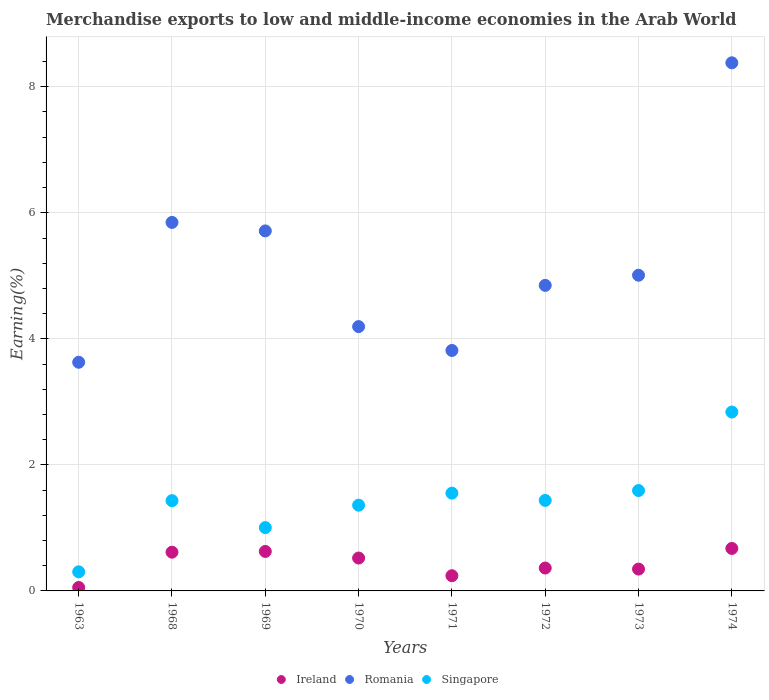How many different coloured dotlines are there?
Make the answer very short. 3. What is the percentage of amount earned from merchandise exports in Romania in 1974?
Your answer should be compact. 8.38. Across all years, what is the maximum percentage of amount earned from merchandise exports in Ireland?
Your answer should be very brief. 0.67. Across all years, what is the minimum percentage of amount earned from merchandise exports in Romania?
Give a very brief answer. 3.63. In which year was the percentage of amount earned from merchandise exports in Ireland maximum?
Your answer should be very brief. 1974. In which year was the percentage of amount earned from merchandise exports in Ireland minimum?
Keep it short and to the point. 1963. What is the total percentage of amount earned from merchandise exports in Singapore in the graph?
Provide a succinct answer. 11.52. What is the difference between the percentage of amount earned from merchandise exports in Singapore in 1972 and that in 1973?
Ensure brevity in your answer.  -0.16. What is the difference between the percentage of amount earned from merchandise exports in Ireland in 1969 and the percentage of amount earned from merchandise exports in Singapore in 1974?
Provide a short and direct response. -2.21. What is the average percentage of amount earned from merchandise exports in Romania per year?
Ensure brevity in your answer.  5.18. In the year 1971, what is the difference between the percentage of amount earned from merchandise exports in Romania and percentage of amount earned from merchandise exports in Singapore?
Your response must be concise. 2.26. In how many years, is the percentage of amount earned from merchandise exports in Romania greater than 4.8 %?
Offer a very short reply. 5. What is the ratio of the percentage of amount earned from merchandise exports in Romania in 1968 to that in 1970?
Keep it short and to the point. 1.39. Is the percentage of amount earned from merchandise exports in Ireland in 1968 less than that in 1969?
Provide a short and direct response. Yes. What is the difference between the highest and the second highest percentage of amount earned from merchandise exports in Romania?
Your response must be concise. 2.53. What is the difference between the highest and the lowest percentage of amount earned from merchandise exports in Romania?
Your response must be concise. 4.75. In how many years, is the percentage of amount earned from merchandise exports in Singapore greater than the average percentage of amount earned from merchandise exports in Singapore taken over all years?
Provide a succinct answer. 3. Is it the case that in every year, the sum of the percentage of amount earned from merchandise exports in Romania and percentage of amount earned from merchandise exports in Singapore  is greater than the percentage of amount earned from merchandise exports in Ireland?
Offer a terse response. Yes. Is the percentage of amount earned from merchandise exports in Singapore strictly greater than the percentage of amount earned from merchandise exports in Romania over the years?
Your answer should be compact. No. Does the graph contain any zero values?
Offer a terse response. No. What is the title of the graph?
Ensure brevity in your answer.  Merchandise exports to low and middle-income economies in the Arab World. Does "Maldives" appear as one of the legend labels in the graph?
Offer a terse response. No. What is the label or title of the X-axis?
Your response must be concise. Years. What is the label or title of the Y-axis?
Provide a short and direct response. Earning(%). What is the Earning(%) of Ireland in 1963?
Offer a very short reply. 0.05. What is the Earning(%) in Romania in 1963?
Ensure brevity in your answer.  3.63. What is the Earning(%) of Singapore in 1963?
Your response must be concise. 0.3. What is the Earning(%) of Ireland in 1968?
Give a very brief answer. 0.61. What is the Earning(%) of Romania in 1968?
Ensure brevity in your answer.  5.85. What is the Earning(%) of Singapore in 1968?
Offer a very short reply. 1.43. What is the Earning(%) of Ireland in 1969?
Your response must be concise. 0.63. What is the Earning(%) in Romania in 1969?
Your answer should be compact. 5.71. What is the Earning(%) in Singapore in 1969?
Provide a succinct answer. 1. What is the Earning(%) of Ireland in 1970?
Your answer should be compact. 0.52. What is the Earning(%) of Romania in 1970?
Ensure brevity in your answer.  4.19. What is the Earning(%) of Singapore in 1970?
Make the answer very short. 1.36. What is the Earning(%) in Ireland in 1971?
Make the answer very short. 0.24. What is the Earning(%) in Romania in 1971?
Your answer should be very brief. 3.82. What is the Earning(%) of Singapore in 1971?
Your answer should be very brief. 1.55. What is the Earning(%) of Ireland in 1972?
Make the answer very short. 0.36. What is the Earning(%) of Romania in 1972?
Provide a short and direct response. 4.85. What is the Earning(%) in Singapore in 1972?
Ensure brevity in your answer.  1.44. What is the Earning(%) in Ireland in 1973?
Provide a short and direct response. 0.35. What is the Earning(%) of Romania in 1973?
Make the answer very short. 5.01. What is the Earning(%) of Singapore in 1973?
Your answer should be compact. 1.59. What is the Earning(%) of Ireland in 1974?
Keep it short and to the point. 0.67. What is the Earning(%) in Romania in 1974?
Keep it short and to the point. 8.38. What is the Earning(%) of Singapore in 1974?
Your answer should be very brief. 2.84. Across all years, what is the maximum Earning(%) in Ireland?
Give a very brief answer. 0.67. Across all years, what is the maximum Earning(%) in Romania?
Your answer should be very brief. 8.38. Across all years, what is the maximum Earning(%) of Singapore?
Provide a succinct answer. 2.84. Across all years, what is the minimum Earning(%) of Ireland?
Your answer should be very brief. 0.05. Across all years, what is the minimum Earning(%) in Romania?
Ensure brevity in your answer.  3.63. Across all years, what is the minimum Earning(%) of Singapore?
Ensure brevity in your answer.  0.3. What is the total Earning(%) in Ireland in the graph?
Give a very brief answer. 3.44. What is the total Earning(%) of Romania in the graph?
Keep it short and to the point. 41.44. What is the total Earning(%) in Singapore in the graph?
Offer a very short reply. 11.52. What is the difference between the Earning(%) of Ireland in 1963 and that in 1968?
Ensure brevity in your answer.  -0.56. What is the difference between the Earning(%) of Romania in 1963 and that in 1968?
Provide a short and direct response. -2.22. What is the difference between the Earning(%) in Singapore in 1963 and that in 1968?
Offer a terse response. -1.13. What is the difference between the Earning(%) in Ireland in 1963 and that in 1969?
Make the answer very short. -0.57. What is the difference between the Earning(%) in Romania in 1963 and that in 1969?
Provide a short and direct response. -2.08. What is the difference between the Earning(%) of Singapore in 1963 and that in 1969?
Offer a terse response. -0.7. What is the difference between the Earning(%) of Ireland in 1963 and that in 1970?
Provide a succinct answer. -0.47. What is the difference between the Earning(%) in Romania in 1963 and that in 1970?
Offer a very short reply. -0.57. What is the difference between the Earning(%) of Singapore in 1963 and that in 1970?
Your answer should be very brief. -1.06. What is the difference between the Earning(%) of Ireland in 1963 and that in 1971?
Make the answer very short. -0.19. What is the difference between the Earning(%) of Romania in 1963 and that in 1971?
Your response must be concise. -0.19. What is the difference between the Earning(%) in Singapore in 1963 and that in 1971?
Make the answer very short. -1.25. What is the difference between the Earning(%) of Ireland in 1963 and that in 1972?
Your answer should be very brief. -0.31. What is the difference between the Earning(%) of Romania in 1963 and that in 1972?
Make the answer very short. -1.22. What is the difference between the Earning(%) of Singapore in 1963 and that in 1972?
Your answer should be very brief. -1.13. What is the difference between the Earning(%) in Ireland in 1963 and that in 1973?
Offer a terse response. -0.29. What is the difference between the Earning(%) in Romania in 1963 and that in 1973?
Offer a very short reply. -1.38. What is the difference between the Earning(%) in Singapore in 1963 and that in 1973?
Keep it short and to the point. -1.29. What is the difference between the Earning(%) of Ireland in 1963 and that in 1974?
Provide a short and direct response. -0.62. What is the difference between the Earning(%) in Romania in 1963 and that in 1974?
Offer a very short reply. -4.75. What is the difference between the Earning(%) of Singapore in 1963 and that in 1974?
Ensure brevity in your answer.  -2.54. What is the difference between the Earning(%) of Ireland in 1968 and that in 1969?
Make the answer very short. -0.01. What is the difference between the Earning(%) in Romania in 1968 and that in 1969?
Your answer should be very brief. 0.13. What is the difference between the Earning(%) of Singapore in 1968 and that in 1969?
Your answer should be compact. 0.43. What is the difference between the Earning(%) in Ireland in 1968 and that in 1970?
Provide a short and direct response. 0.09. What is the difference between the Earning(%) in Romania in 1968 and that in 1970?
Give a very brief answer. 1.65. What is the difference between the Earning(%) of Singapore in 1968 and that in 1970?
Offer a terse response. 0.07. What is the difference between the Earning(%) of Ireland in 1968 and that in 1971?
Provide a succinct answer. 0.37. What is the difference between the Earning(%) in Romania in 1968 and that in 1971?
Offer a very short reply. 2.03. What is the difference between the Earning(%) of Singapore in 1968 and that in 1971?
Ensure brevity in your answer.  -0.12. What is the difference between the Earning(%) in Ireland in 1968 and that in 1972?
Keep it short and to the point. 0.25. What is the difference between the Earning(%) of Singapore in 1968 and that in 1972?
Give a very brief answer. -0. What is the difference between the Earning(%) of Ireland in 1968 and that in 1973?
Make the answer very short. 0.27. What is the difference between the Earning(%) in Romania in 1968 and that in 1973?
Your answer should be compact. 0.84. What is the difference between the Earning(%) in Singapore in 1968 and that in 1973?
Offer a terse response. -0.16. What is the difference between the Earning(%) in Ireland in 1968 and that in 1974?
Keep it short and to the point. -0.06. What is the difference between the Earning(%) of Romania in 1968 and that in 1974?
Keep it short and to the point. -2.53. What is the difference between the Earning(%) of Singapore in 1968 and that in 1974?
Offer a terse response. -1.41. What is the difference between the Earning(%) in Ireland in 1969 and that in 1970?
Your answer should be very brief. 0.1. What is the difference between the Earning(%) in Romania in 1969 and that in 1970?
Make the answer very short. 1.52. What is the difference between the Earning(%) in Singapore in 1969 and that in 1970?
Your response must be concise. -0.36. What is the difference between the Earning(%) in Ireland in 1969 and that in 1971?
Your answer should be very brief. 0.39. What is the difference between the Earning(%) in Romania in 1969 and that in 1971?
Offer a terse response. 1.9. What is the difference between the Earning(%) in Singapore in 1969 and that in 1971?
Offer a terse response. -0.55. What is the difference between the Earning(%) of Ireland in 1969 and that in 1972?
Offer a very short reply. 0.26. What is the difference between the Earning(%) in Romania in 1969 and that in 1972?
Offer a very short reply. 0.86. What is the difference between the Earning(%) of Singapore in 1969 and that in 1972?
Make the answer very short. -0.43. What is the difference between the Earning(%) of Ireland in 1969 and that in 1973?
Provide a succinct answer. 0.28. What is the difference between the Earning(%) of Romania in 1969 and that in 1973?
Ensure brevity in your answer.  0.7. What is the difference between the Earning(%) of Singapore in 1969 and that in 1973?
Your answer should be compact. -0.59. What is the difference between the Earning(%) of Ireland in 1969 and that in 1974?
Your response must be concise. -0.05. What is the difference between the Earning(%) in Romania in 1969 and that in 1974?
Ensure brevity in your answer.  -2.67. What is the difference between the Earning(%) in Singapore in 1969 and that in 1974?
Make the answer very short. -1.83. What is the difference between the Earning(%) of Ireland in 1970 and that in 1971?
Your answer should be very brief. 0.28. What is the difference between the Earning(%) in Romania in 1970 and that in 1971?
Offer a very short reply. 0.38. What is the difference between the Earning(%) of Singapore in 1970 and that in 1971?
Ensure brevity in your answer.  -0.19. What is the difference between the Earning(%) in Ireland in 1970 and that in 1972?
Keep it short and to the point. 0.16. What is the difference between the Earning(%) in Romania in 1970 and that in 1972?
Your response must be concise. -0.65. What is the difference between the Earning(%) of Singapore in 1970 and that in 1972?
Ensure brevity in your answer.  -0.08. What is the difference between the Earning(%) in Ireland in 1970 and that in 1973?
Offer a terse response. 0.18. What is the difference between the Earning(%) of Romania in 1970 and that in 1973?
Your response must be concise. -0.82. What is the difference between the Earning(%) in Singapore in 1970 and that in 1973?
Your answer should be compact. -0.23. What is the difference between the Earning(%) of Ireland in 1970 and that in 1974?
Your response must be concise. -0.15. What is the difference between the Earning(%) in Romania in 1970 and that in 1974?
Offer a very short reply. -4.19. What is the difference between the Earning(%) of Singapore in 1970 and that in 1974?
Provide a succinct answer. -1.48. What is the difference between the Earning(%) in Ireland in 1971 and that in 1972?
Make the answer very short. -0.12. What is the difference between the Earning(%) in Romania in 1971 and that in 1972?
Offer a very short reply. -1.03. What is the difference between the Earning(%) in Singapore in 1971 and that in 1972?
Offer a terse response. 0.11. What is the difference between the Earning(%) in Ireland in 1971 and that in 1973?
Your answer should be very brief. -0.11. What is the difference between the Earning(%) of Romania in 1971 and that in 1973?
Make the answer very short. -1.19. What is the difference between the Earning(%) of Singapore in 1971 and that in 1973?
Provide a succinct answer. -0.04. What is the difference between the Earning(%) in Ireland in 1971 and that in 1974?
Your response must be concise. -0.43. What is the difference between the Earning(%) of Romania in 1971 and that in 1974?
Your response must be concise. -4.56. What is the difference between the Earning(%) of Singapore in 1971 and that in 1974?
Your answer should be compact. -1.29. What is the difference between the Earning(%) of Ireland in 1972 and that in 1973?
Provide a succinct answer. 0.02. What is the difference between the Earning(%) in Romania in 1972 and that in 1973?
Ensure brevity in your answer.  -0.16. What is the difference between the Earning(%) of Singapore in 1972 and that in 1973?
Provide a succinct answer. -0.16. What is the difference between the Earning(%) of Ireland in 1972 and that in 1974?
Make the answer very short. -0.31. What is the difference between the Earning(%) of Romania in 1972 and that in 1974?
Provide a succinct answer. -3.53. What is the difference between the Earning(%) of Singapore in 1972 and that in 1974?
Your response must be concise. -1.4. What is the difference between the Earning(%) of Ireland in 1973 and that in 1974?
Your answer should be very brief. -0.33. What is the difference between the Earning(%) of Romania in 1973 and that in 1974?
Offer a terse response. -3.37. What is the difference between the Earning(%) in Singapore in 1973 and that in 1974?
Your answer should be compact. -1.25. What is the difference between the Earning(%) in Ireland in 1963 and the Earning(%) in Romania in 1968?
Provide a succinct answer. -5.79. What is the difference between the Earning(%) in Ireland in 1963 and the Earning(%) in Singapore in 1968?
Your answer should be very brief. -1.38. What is the difference between the Earning(%) of Romania in 1963 and the Earning(%) of Singapore in 1968?
Make the answer very short. 2.2. What is the difference between the Earning(%) in Ireland in 1963 and the Earning(%) in Romania in 1969?
Provide a succinct answer. -5.66. What is the difference between the Earning(%) of Ireland in 1963 and the Earning(%) of Singapore in 1969?
Your answer should be very brief. -0.95. What is the difference between the Earning(%) of Romania in 1963 and the Earning(%) of Singapore in 1969?
Provide a succinct answer. 2.62. What is the difference between the Earning(%) in Ireland in 1963 and the Earning(%) in Romania in 1970?
Make the answer very short. -4.14. What is the difference between the Earning(%) in Ireland in 1963 and the Earning(%) in Singapore in 1970?
Offer a very short reply. -1.31. What is the difference between the Earning(%) in Romania in 1963 and the Earning(%) in Singapore in 1970?
Provide a short and direct response. 2.27. What is the difference between the Earning(%) in Ireland in 1963 and the Earning(%) in Romania in 1971?
Your answer should be very brief. -3.76. What is the difference between the Earning(%) of Ireland in 1963 and the Earning(%) of Singapore in 1971?
Your answer should be compact. -1.5. What is the difference between the Earning(%) of Romania in 1963 and the Earning(%) of Singapore in 1971?
Provide a short and direct response. 2.08. What is the difference between the Earning(%) of Ireland in 1963 and the Earning(%) of Romania in 1972?
Your answer should be compact. -4.79. What is the difference between the Earning(%) of Ireland in 1963 and the Earning(%) of Singapore in 1972?
Provide a succinct answer. -1.38. What is the difference between the Earning(%) in Romania in 1963 and the Earning(%) in Singapore in 1972?
Make the answer very short. 2.19. What is the difference between the Earning(%) in Ireland in 1963 and the Earning(%) in Romania in 1973?
Provide a short and direct response. -4.95. What is the difference between the Earning(%) of Ireland in 1963 and the Earning(%) of Singapore in 1973?
Keep it short and to the point. -1.54. What is the difference between the Earning(%) of Romania in 1963 and the Earning(%) of Singapore in 1973?
Your answer should be compact. 2.04. What is the difference between the Earning(%) in Ireland in 1963 and the Earning(%) in Romania in 1974?
Give a very brief answer. -8.33. What is the difference between the Earning(%) of Ireland in 1963 and the Earning(%) of Singapore in 1974?
Your answer should be compact. -2.78. What is the difference between the Earning(%) in Romania in 1963 and the Earning(%) in Singapore in 1974?
Provide a succinct answer. 0.79. What is the difference between the Earning(%) of Ireland in 1968 and the Earning(%) of Romania in 1969?
Make the answer very short. -5.1. What is the difference between the Earning(%) in Ireland in 1968 and the Earning(%) in Singapore in 1969?
Provide a succinct answer. -0.39. What is the difference between the Earning(%) of Romania in 1968 and the Earning(%) of Singapore in 1969?
Provide a succinct answer. 4.84. What is the difference between the Earning(%) in Ireland in 1968 and the Earning(%) in Romania in 1970?
Give a very brief answer. -3.58. What is the difference between the Earning(%) of Ireland in 1968 and the Earning(%) of Singapore in 1970?
Give a very brief answer. -0.75. What is the difference between the Earning(%) in Romania in 1968 and the Earning(%) in Singapore in 1970?
Provide a short and direct response. 4.49. What is the difference between the Earning(%) in Ireland in 1968 and the Earning(%) in Romania in 1971?
Your answer should be very brief. -3.2. What is the difference between the Earning(%) in Ireland in 1968 and the Earning(%) in Singapore in 1971?
Your answer should be very brief. -0.94. What is the difference between the Earning(%) of Romania in 1968 and the Earning(%) of Singapore in 1971?
Give a very brief answer. 4.3. What is the difference between the Earning(%) of Ireland in 1968 and the Earning(%) of Romania in 1972?
Make the answer very short. -4.23. What is the difference between the Earning(%) of Ireland in 1968 and the Earning(%) of Singapore in 1972?
Provide a succinct answer. -0.82. What is the difference between the Earning(%) of Romania in 1968 and the Earning(%) of Singapore in 1972?
Your answer should be compact. 4.41. What is the difference between the Earning(%) of Ireland in 1968 and the Earning(%) of Romania in 1973?
Provide a succinct answer. -4.39. What is the difference between the Earning(%) of Ireland in 1968 and the Earning(%) of Singapore in 1973?
Your answer should be compact. -0.98. What is the difference between the Earning(%) in Romania in 1968 and the Earning(%) in Singapore in 1973?
Your answer should be very brief. 4.25. What is the difference between the Earning(%) of Ireland in 1968 and the Earning(%) of Romania in 1974?
Ensure brevity in your answer.  -7.77. What is the difference between the Earning(%) in Ireland in 1968 and the Earning(%) in Singapore in 1974?
Offer a terse response. -2.22. What is the difference between the Earning(%) of Romania in 1968 and the Earning(%) of Singapore in 1974?
Your answer should be very brief. 3.01. What is the difference between the Earning(%) in Ireland in 1969 and the Earning(%) in Romania in 1970?
Your answer should be very brief. -3.57. What is the difference between the Earning(%) in Ireland in 1969 and the Earning(%) in Singapore in 1970?
Give a very brief answer. -0.73. What is the difference between the Earning(%) in Romania in 1969 and the Earning(%) in Singapore in 1970?
Make the answer very short. 4.35. What is the difference between the Earning(%) in Ireland in 1969 and the Earning(%) in Romania in 1971?
Provide a succinct answer. -3.19. What is the difference between the Earning(%) of Ireland in 1969 and the Earning(%) of Singapore in 1971?
Provide a succinct answer. -0.92. What is the difference between the Earning(%) in Romania in 1969 and the Earning(%) in Singapore in 1971?
Your response must be concise. 4.16. What is the difference between the Earning(%) in Ireland in 1969 and the Earning(%) in Romania in 1972?
Provide a short and direct response. -4.22. What is the difference between the Earning(%) of Ireland in 1969 and the Earning(%) of Singapore in 1972?
Provide a succinct answer. -0.81. What is the difference between the Earning(%) of Romania in 1969 and the Earning(%) of Singapore in 1972?
Give a very brief answer. 4.28. What is the difference between the Earning(%) of Ireland in 1969 and the Earning(%) of Romania in 1973?
Offer a terse response. -4.38. What is the difference between the Earning(%) in Ireland in 1969 and the Earning(%) in Singapore in 1973?
Provide a succinct answer. -0.97. What is the difference between the Earning(%) in Romania in 1969 and the Earning(%) in Singapore in 1973?
Offer a terse response. 4.12. What is the difference between the Earning(%) in Ireland in 1969 and the Earning(%) in Romania in 1974?
Keep it short and to the point. -7.75. What is the difference between the Earning(%) in Ireland in 1969 and the Earning(%) in Singapore in 1974?
Your answer should be compact. -2.21. What is the difference between the Earning(%) of Romania in 1969 and the Earning(%) of Singapore in 1974?
Offer a terse response. 2.87. What is the difference between the Earning(%) of Ireland in 1970 and the Earning(%) of Romania in 1971?
Your answer should be compact. -3.29. What is the difference between the Earning(%) in Ireland in 1970 and the Earning(%) in Singapore in 1971?
Provide a succinct answer. -1.03. What is the difference between the Earning(%) in Romania in 1970 and the Earning(%) in Singapore in 1971?
Ensure brevity in your answer.  2.64. What is the difference between the Earning(%) in Ireland in 1970 and the Earning(%) in Romania in 1972?
Keep it short and to the point. -4.33. What is the difference between the Earning(%) of Ireland in 1970 and the Earning(%) of Singapore in 1972?
Provide a short and direct response. -0.91. What is the difference between the Earning(%) in Romania in 1970 and the Earning(%) in Singapore in 1972?
Make the answer very short. 2.76. What is the difference between the Earning(%) in Ireland in 1970 and the Earning(%) in Romania in 1973?
Offer a very short reply. -4.49. What is the difference between the Earning(%) of Ireland in 1970 and the Earning(%) of Singapore in 1973?
Offer a terse response. -1.07. What is the difference between the Earning(%) in Romania in 1970 and the Earning(%) in Singapore in 1973?
Offer a terse response. 2.6. What is the difference between the Earning(%) of Ireland in 1970 and the Earning(%) of Romania in 1974?
Offer a terse response. -7.86. What is the difference between the Earning(%) of Ireland in 1970 and the Earning(%) of Singapore in 1974?
Make the answer very short. -2.32. What is the difference between the Earning(%) in Romania in 1970 and the Earning(%) in Singapore in 1974?
Provide a short and direct response. 1.36. What is the difference between the Earning(%) in Ireland in 1971 and the Earning(%) in Romania in 1972?
Make the answer very short. -4.61. What is the difference between the Earning(%) in Ireland in 1971 and the Earning(%) in Singapore in 1972?
Offer a terse response. -1.2. What is the difference between the Earning(%) of Romania in 1971 and the Earning(%) of Singapore in 1972?
Offer a terse response. 2.38. What is the difference between the Earning(%) in Ireland in 1971 and the Earning(%) in Romania in 1973?
Ensure brevity in your answer.  -4.77. What is the difference between the Earning(%) of Ireland in 1971 and the Earning(%) of Singapore in 1973?
Your response must be concise. -1.35. What is the difference between the Earning(%) of Romania in 1971 and the Earning(%) of Singapore in 1973?
Make the answer very short. 2.22. What is the difference between the Earning(%) in Ireland in 1971 and the Earning(%) in Romania in 1974?
Keep it short and to the point. -8.14. What is the difference between the Earning(%) of Ireland in 1971 and the Earning(%) of Singapore in 1974?
Provide a short and direct response. -2.6. What is the difference between the Earning(%) in Romania in 1971 and the Earning(%) in Singapore in 1974?
Offer a very short reply. 0.98. What is the difference between the Earning(%) in Ireland in 1972 and the Earning(%) in Romania in 1973?
Ensure brevity in your answer.  -4.65. What is the difference between the Earning(%) in Ireland in 1972 and the Earning(%) in Singapore in 1973?
Make the answer very short. -1.23. What is the difference between the Earning(%) in Romania in 1972 and the Earning(%) in Singapore in 1973?
Provide a succinct answer. 3.26. What is the difference between the Earning(%) in Ireland in 1972 and the Earning(%) in Romania in 1974?
Your answer should be compact. -8.02. What is the difference between the Earning(%) in Ireland in 1972 and the Earning(%) in Singapore in 1974?
Make the answer very short. -2.48. What is the difference between the Earning(%) of Romania in 1972 and the Earning(%) of Singapore in 1974?
Offer a terse response. 2.01. What is the difference between the Earning(%) of Ireland in 1973 and the Earning(%) of Romania in 1974?
Give a very brief answer. -8.03. What is the difference between the Earning(%) of Ireland in 1973 and the Earning(%) of Singapore in 1974?
Ensure brevity in your answer.  -2.49. What is the difference between the Earning(%) of Romania in 1973 and the Earning(%) of Singapore in 1974?
Offer a very short reply. 2.17. What is the average Earning(%) of Ireland per year?
Offer a terse response. 0.43. What is the average Earning(%) in Romania per year?
Offer a very short reply. 5.18. What is the average Earning(%) in Singapore per year?
Provide a succinct answer. 1.44. In the year 1963, what is the difference between the Earning(%) of Ireland and Earning(%) of Romania?
Provide a succinct answer. -3.57. In the year 1963, what is the difference between the Earning(%) of Ireland and Earning(%) of Singapore?
Keep it short and to the point. -0.25. In the year 1963, what is the difference between the Earning(%) in Romania and Earning(%) in Singapore?
Keep it short and to the point. 3.33. In the year 1968, what is the difference between the Earning(%) of Ireland and Earning(%) of Romania?
Keep it short and to the point. -5.23. In the year 1968, what is the difference between the Earning(%) of Ireland and Earning(%) of Singapore?
Keep it short and to the point. -0.82. In the year 1968, what is the difference between the Earning(%) in Romania and Earning(%) in Singapore?
Offer a very short reply. 4.42. In the year 1969, what is the difference between the Earning(%) of Ireland and Earning(%) of Romania?
Your response must be concise. -5.09. In the year 1969, what is the difference between the Earning(%) of Ireland and Earning(%) of Singapore?
Make the answer very short. -0.38. In the year 1969, what is the difference between the Earning(%) of Romania and Earning(%) of Singapore?
Ensure brevity in your answer.  4.71. In the year 1970, what is the difference between the Earning(%) of Ireland and Earning(%) of Romania?
Ensure brevity in your answer.  -3.67. In the year 1970, what is the difference between the Earning(%) in Ireland and Earning(%) in Singapore?
Ensure brevity in your answer.  -0.84. In the year 1970, what is the difference between the Earning(%) of Romania and Earning(%) of Singapore?
Offer a very short reply. 2.83. In the year 1971, what is the difference between the Earning(%) in Ireland and Earning(%) in Romania?
Your answer should be very brief. -3.57. In the year 1971, what is the difference between the Earning(%) in Ireland and Earning(%) in Singapore?
Provide a succinct answer. -1.31. In the year 1971, what is the difference between the Earning(%) of Romania and Earning(%) of Singapore?
Provide a short and direct response. 2.26. In the year 1972, what is the difference between the Earning(%) of Ireland and Earning(%) of Romania?
Offer a terse response. -4.49. In the year 1972, what is the difference between the Earning(%) in Ireland and Earning(%) in Singapore?
Offer a very short reply. -1.07. In the year 1972, what is the difference between the Earning(%) of Romania and Earning(%) of Singapore?
Give a very brief answer. 3.41. In the year 1973, what is the difference between the Earning(%) in Ireland and Earning(%) in Romania?
Provide a succinct answer. -4.66. In the year 1973, what is the difference between the Earning(%) in Ireland and Earning(%) in Singapore?
Your response must be concise. -1.25. In the year 1973, what is the difference between the Earning(%) in Romania and Earning(%) in Singapore?
Your answer should be very brief. 3.42. In the year 1974, what is the difference between the Earning(%) in Ireland and Earning(%) in Romania?
Give a very brief answer. -7.71. In the year 1974, what is the difference between the Earning(%) in Ireland and Earning(%) in Singapore?
Keep it short and to the point. -2.16. In the year 1974, what is the difference between the Earning(%) in Romania and Earning(%) in Singapore?
Your answer should be compact. 5.54. What is the ratio of the Earning(%) of Ireland in 1963 to that in 1968?
Your response must be concise. 0.09. What is the ratio of the Earning(%) in Romania in 1963 to that in 1968?
Your answer should be compact. 0.62. What is the ratio of the Earning(%) of Singapore in 1963 to that in 1968?
Provide a succinct answer. 0.21. What is the ratio of the Earning(%) in Ireland in 1963 to that in 1969?
Your answer should be compact. 0.09. What is the ratio of the Earning(%) of Romania in 1963 to that in 1969?
Keep it short and to the point. 0.64. What is the ratio of the Earning(%) in Singapore in 1963 to that in 1969?
Offer a terse response. 0.3. What is the ratio of the Earning(%) in Ireland in 1963 to that in 1970?
Keep it short and to the point. 0.1. What is the ratio of the Earning(%) of Romania in 1963 to that in 1970?
Your answer should be very brief. 0.87. What is the ratio of the Earning(%) of Singapore in 1963 to that in 1970?
Offer a terse response. 0.22. What is the ratio of the Earning(%) in Ireland in 1963 to that in 1971?
Keep it short and to the point. 0.23. What is the ratio of the Earning(%) of Romania in 1963 to that in 1971?
Provide a short and direct response. 0.95. What is the ratio of the Earning(%) of Singapore in 1963 to that in 1971?
Offer a very short reply. 0.2. What is the ratio of the Earning(%) in Ireland in 1963 to that in 1972?
Keep it short and to the point. 0.15. What is the ratio of the Earning(%) of Romania in 1963 to that in 1972?
Offer a very short reply. 0.75. What is the ratio of the Earning(%) of Singapore in 1963 to that in 1972?
Provide a short and direct response. 0.21. What is the ratio of the Earning(%) of Ireland in 1963 to that in 1973?
Your answer should be compact. 0.16. What is the ratio of the Earning(%) of Romania in 1963 to that in 1973?
Ensure brevity in your answer.  0.72. What is the ratio of the Earning(%) of Singapore in 1963 to that in 1973?
Your response must be concise. 0.19. What is the ratio of the Earning(%) of Ireland in 1963 to that in 1974?
Your answer should be very brief. 0.08. What is the ratio of the Earning(%) of Romania in 1963 to that in 1974?
Offer a terse response. 0.43. What is the ratio of the Earning(%) of Singapore in 1963 to that in 1974?
Ensure brevity in your answer.  0.11. What is the ratio of the Earning(%) in Ireland in 1968 to that in 1969?
Provide a succinct answer. 0.98. What is the ratio of the Earning(%) in Romania in 1968 to that in 1969?
Your response must be concise. 1.02. What is the ratio of the Earning(%) in Singapore in 1968 to that in 1969?
Your response must be concise. 1.43. What is the ratio of the Earning(%) in Ireland in 1968 to that in 1970?
Give a very brief answer. 1.18. What is the ratio of the Earning(%) in Romania in 1968 to that in 1970?
Offer a very short reply. 1.39. What is the ratio of the Earning(%) of Singapore in 1968 to that in 1970?
Your response must be concise. 1.05. What is the ratio of the Earning(%) in Ireland in 1968 to that in 1971?
Make the answer very short. 2.55. What is the ratio of the Earning(%) in Romania in 1968 to that in 1971?
Offer a terse response. 1.53. What is the ratio of the Earning(%) of Singapore in 1968 to that in 1971?
Your answer should be very brief. 0.92. What is the ratio of the Earning(%) in Ireland in 1968 to that in 1972?
Provide a short and direct response. 1.69. What is the ratio of the Earning(%) in Romania in 1968 to that in 1972?
Keep it short and to the point. 1.21. What is the ratio of the Earning(%) in Singapore in 1968 to that in 1972?
Ensure brevity in your answer.  1. What is the ratio of the Earning(%) of Ireland in 1968 to that in 1973?
Keep it short and to the point. 1.77. What is the ratio of the Earning(%) in Romania in 1968 to that in 1973?
Make the answer very short. 1.17. What is the ratio of the Earning(%) of Singapore in 1968 to that in 1973?
Give a very brief answer. 0.9. What is the ratio of the Earning(%) in Ireland in 1968 to that in 1974?
Your answer should be very brief. 0.91. What is the ratio of the Earning(%) of Romania in 1968 to that in 1974?
Your answer should be compact. 0.7. What is the ratio of the Earning(%) of Singapore in 1968 to that in 1974?
Provide a succinct answer. 0.5. What is the ratio of the Earning(%) in Ireland in 1969 to that in 1970?
Keep it short and to the point. 1.2. What is the ratio of the Earning(%) of Romania in 1969 to that in 1970?
Ensure brevity in your answer.  1.36. What is the ratio of the Earning(%) in Singapore in 1969 to that in 1970?
Keep it short and to the point. 0.74. What is the ratio of the Earning(%) of Ireland in 1969 to that in 1971?
Make the answer very short. 2.6. What is the ratio of the Earning(%) of Romania in 1969 to that in 1971?
Offer a terse response. 1.5. What is the ratio of the Earning(%) of Singapore in 1969 to that in 1971?
Offer a very short reply. 0.65. What is the ratio of the Earning(%) of Ireland in 1969 to that in 1972?
Provide a succinct answer. 1.73. What is the ratio of the Earning(%) of Romania in 1969 to that in 1972?
Keep it short and to the point. 1.18. What is the ratio of the Earning(%) in Singapore in 1969 to that in 1972?
Provide a succinct answer. 0.7. What is the ratio of the Earning(%) of Ireland in 1969 to that in 1973?
Keep it short and to the point. 1.81. What is the ratio of the Earning(%) of Romania in 1969 to that in 1973?
Offer a very short reply. 1.14. What is the ratio of the Earning(%) in Singapore in 1969 to that in 1973?
Offer a terse response. 0.63. What is the ratio of the Earning(%) in Ireland in 1969 to that in 1974?
Your response must be concise. 0.93. What is the ratio of the Earning(%) in Romania in 1969 to that in 1974?
Your response must be concise. 0.68. What is the ratio of the Earning(%) in Singapore in 1969 to that in 1974?
Provide a succinct answer. 0.35. What is the ratio of the Earning(%) of Ireland in 1970 to that in 1971?
Give a very brief answer. 2.16. What is the ratio of the Earning(%) in Romania in 1970 to that in 1971?
Provide a succinct answer. 1.1. What is the ratio of the Earning(%) of Singapore in 1970 to that in 1971?
Your answer should be very brief. 0.88. What is the ratio of the Earning(%) in Ireland in 1970 to that in 1972?
Your answer should be compact. 1.44. What is the ratio of the Earning(%) in Romania in 1970 to that in 1972?
Give a very brief answer. 0.87. What is the ratio of the Earning(%) in Singapore in 1970 to that in 1972?
Your response must be concise. 0.95. What is the ratio of the Earning(%) in Ireland in 1970 to that in 1973?
Provide a succinct answer. 1.51. What is the ratio of the Earning(%) in Romania in 1970 to that in 1973?
Offer a terse response. 0.84. What is the ratio of the Earning(%) of Singapore in 1970 to that in 1973?
Ensure brevity in your answer.  0.85. What is the ratio of the Earning(%) of Ireland in 1970 to that in 1974?
Your answer should be compact. 0.77. What is the ratio of the Earning(%) in Romania in 1970 to that in 1974?
Provide a succinct answer. 0.5. What is the ratio of the Earning(%) in Singapore in 1970 to that in 1974?
Your answer should be very brief. 0.48. What is the ratio of the Earning(%) in Ireland in 1971 to that in 1972?
Ensure brevity in your answer.  0.67. What is the ratio of the Earning(%) of Romania in 1971 to that in 1972?
Give a very brief answer. 0.79. What is the ratio of the Earning(%) of Ireland in 1971 to that in 1973?
Keep it short and to the point. 0.7. What is the ratio of the Earning(%) of Romania in 1971 to that in 1973?
Your answer should be compact. 0.76. What is the ratio of the Earning(%) of Singapore in 1971 to that in 1973?
Make the answer very short. 0.97. What is the ratio of the Earning(%) in Ireland in 1971 to that in 1974?
Provide a short and direct response. 0.36. What is the ratio of the Earning(%) of Romania in 1971 to that in 1974?
Your answer should be compact. 0.46. What is the ratio of the Earning(%) of Singapore in 1971 to that in 1974?
Offer a terse response. 0.55. What is the ratio of the Earning(%) of Ireland in 1972 to that in 1973?
Provide a short and direct response. 1.05. What is the ratio of the Earning(%) in Romania in 1972 to that in 1973?
Keep it short and to the point. 0.97. What is the ratio of the Earning(%) of Singapore in 1972 to that in 1973?
Make the answer very short. 0.9. What is the ratio of the Earning(%) of Ireland in 1972 to that in 1974?
Your answer should be compact. 0.54. What is the ratio of the Earning(%) of Romania in 1972 to that in 1974?
Provide a succinct answer. 0.58. What is the ratio of the Earning(%) in Singapore in 1972 to that in 1974?
Your answer should be compact. 0.51. What is the ratio of the Earning(%) in Ireland in 1973 to that in 1974?
Offer a terse response. 0.51. What is the ratio of the Earning(%) of Romania in 1973 to that in 1974?
Offer a terse response. 0.6. What is the ratio of the Earning(%) of Singapore in 1973 to that in 1974?
Ensure brevity in your answer.  0.56. What is the difference between the highest and the second highest Earning(%) of Ireland?
Your response must be concise. 0.05. What is the difference between the highest and the second highest Earning(%) in Romania?
Offer a terse response. 2.53. What is the difference between the highest and the second highest Earning(%) in Singapore?
Keep it short and to the point. 1.25. What is the difference between the highest and the lowest Earning(%) of Ireland?
Make the answer very short. 0.62. What is the difference between the highest and the lowest Earning(%) of Romania?
Your answer should be very brief. 4.75. What is the difference between the highest and the lowest Earning(%) in Singapore?
Provide a succinct answer. 2.54. 